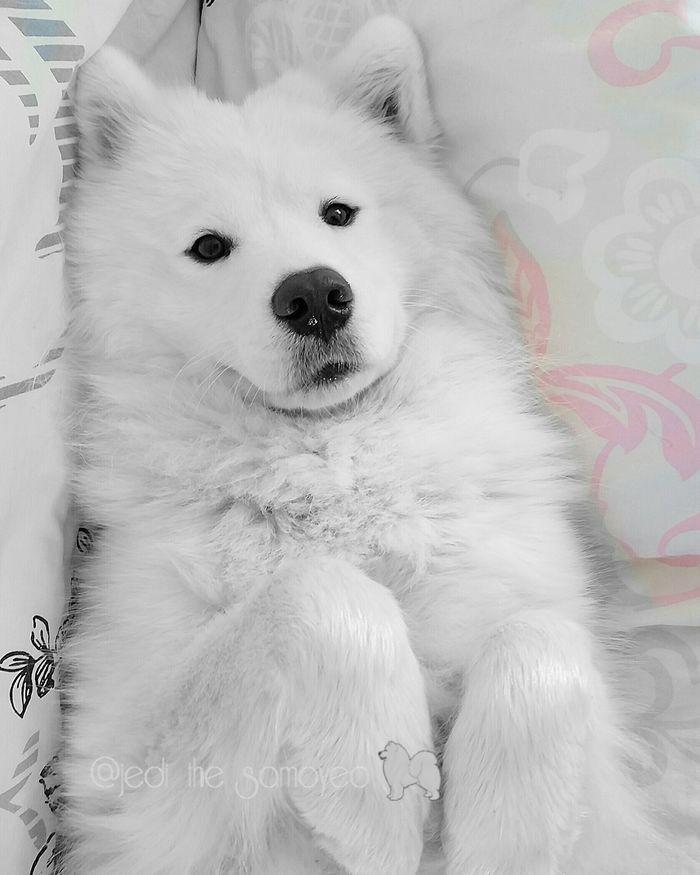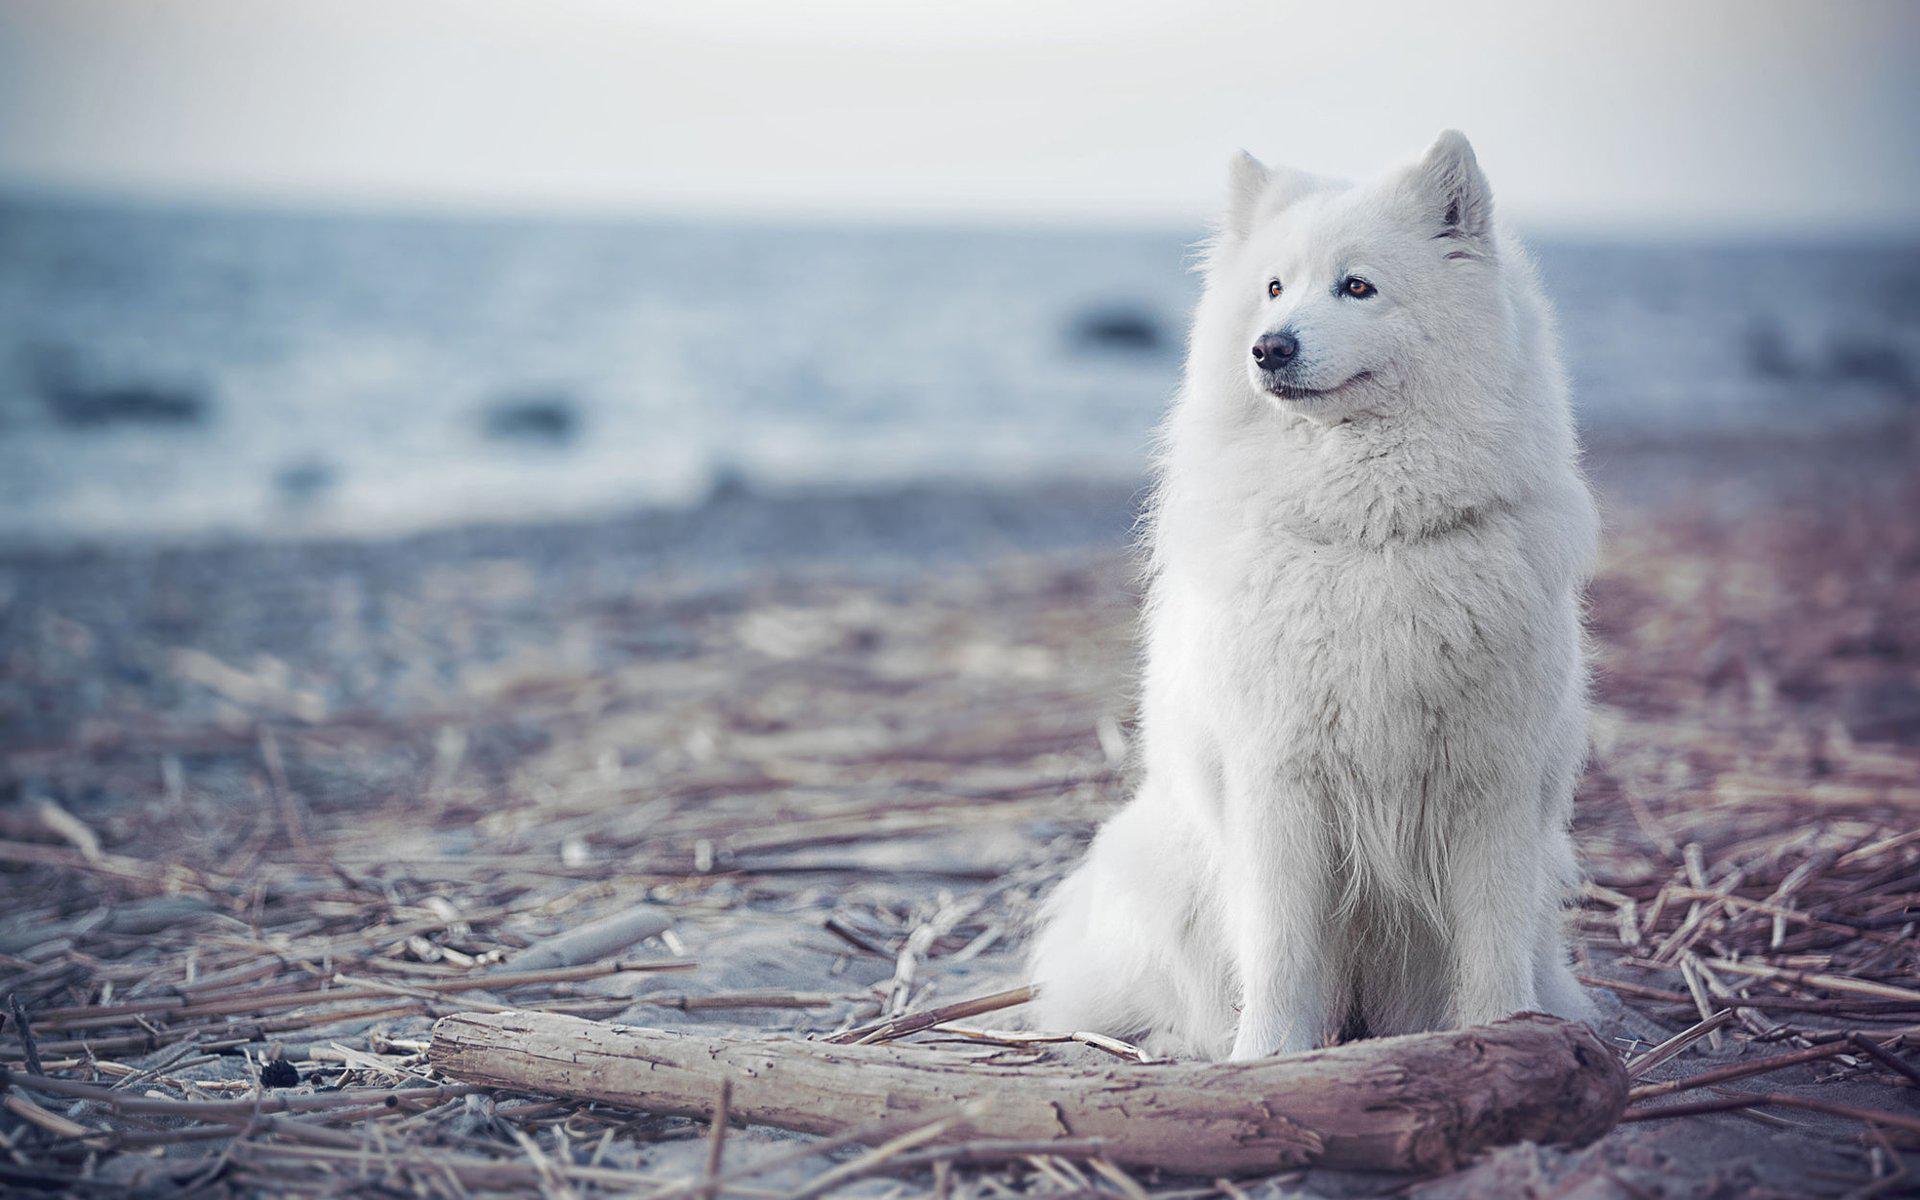The first image is the image on the left, the second image is the image on the right. Analyze the images presented: Is the assertion "The right image contains a white dog facing towards the right." valid? Answer yes or no. No. 